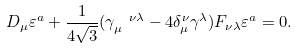Convert formula to latex. <formula><loc_0><loc_0><loc_500><loc_500>D _ { \mu } \varepsilon ^ { a } + \frac { 1 } { 4 \sqrt { 3 } } ( \gamma _ { \mu } ^ { \text { \ \ } \nu \lambda } - 4 \delta _ { \mu } ^ { \nu } \gamma ^ { \lambda } ) F _ { \nu \lambda } \varepsilon ^ { a } = 0 .</formula> 